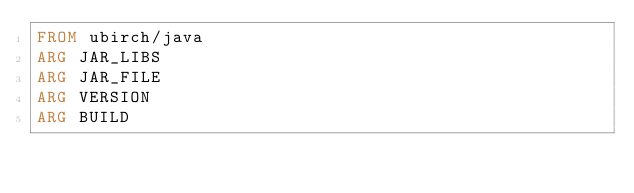<code> <loc_0><loc_0><loc_500><loc_500><_Dockerfile_>FROM ubirch/java
ARG JAR_LIBS
ARG JAR_FILE
ARG VERSION
ARG BUILD</code> 